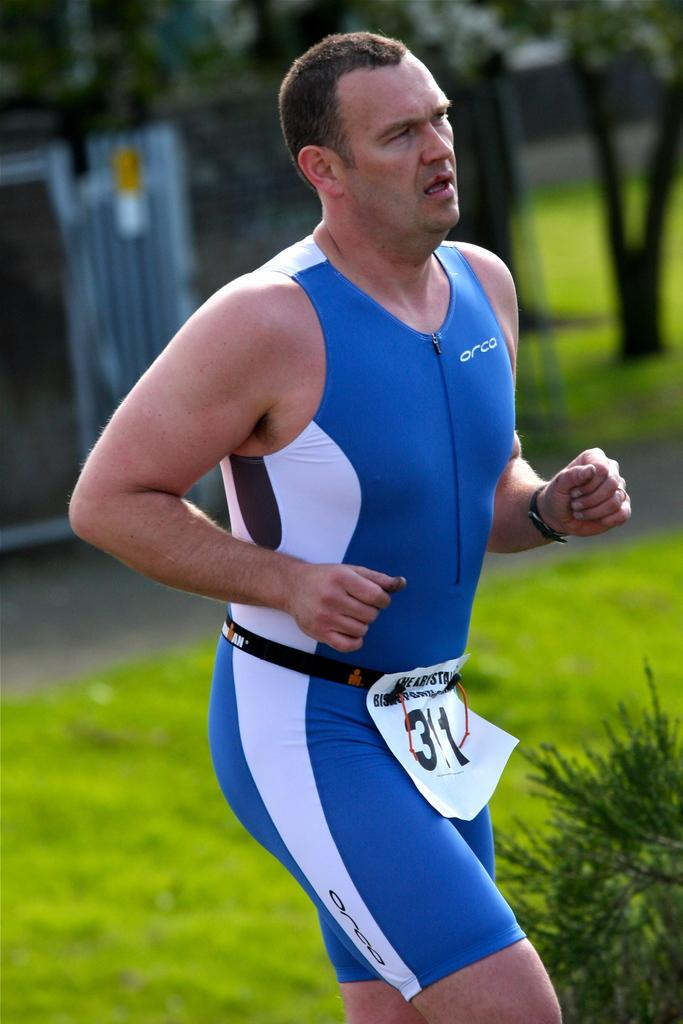<image>
Render a clear and concise summary of the photo. Man wearing a sign which says number 311 on it while he is running. 